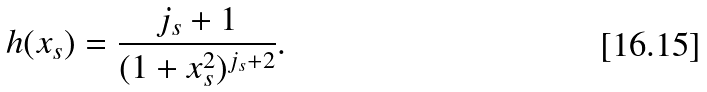Convert formula to latex. <formula><loc_0><loc_0><loc_500><loc_500>h ( x _ { s } ) = \frac { j _ { s } + 1 } { ( 1 + x _ { s } ^ { 2 } ) ^ { j _ { s } + 2 } } .</formula> 